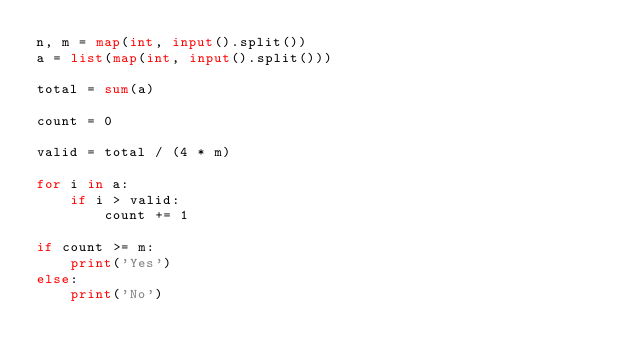Convert code to text. <code><loc_0><loc_0><loc_500><loc_500><_Python_>n, m = map(int, input().split())
a = list(map(int, input().split()))

total = sum(a)

count = 0

valid = total / (4 * m)

for i in a:
    if i > valid:
        count += 1

if count >= m:
    print('Yes')
else:
    print('No')
</code> 